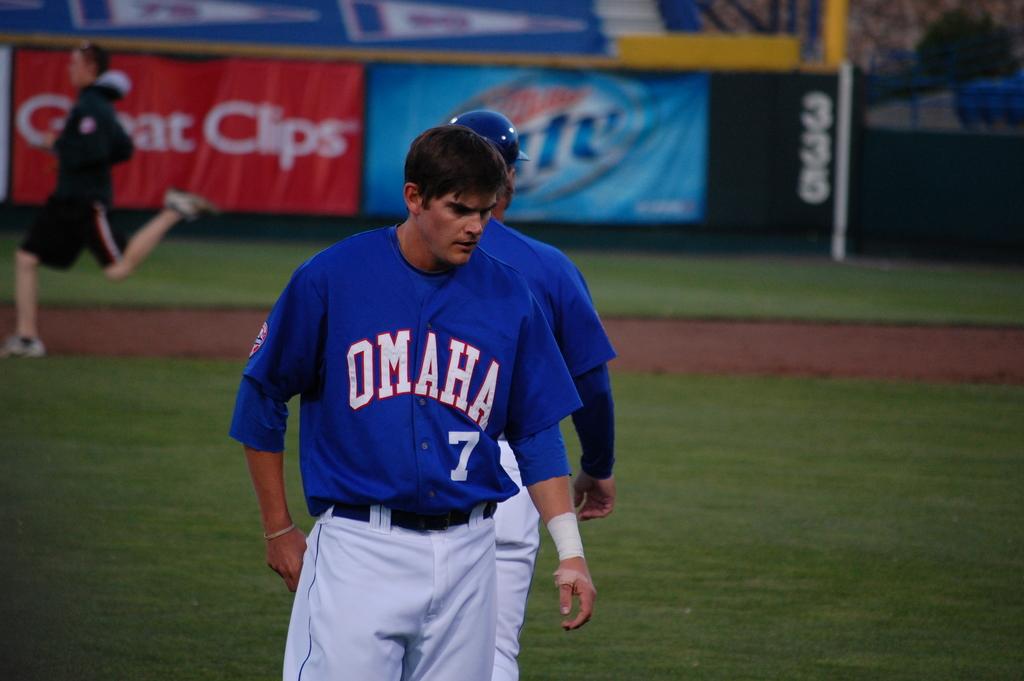What team does he play for?
Ensure brevity in your answer.  Omaha. What number is he?
Give a very brief answer. 7. 